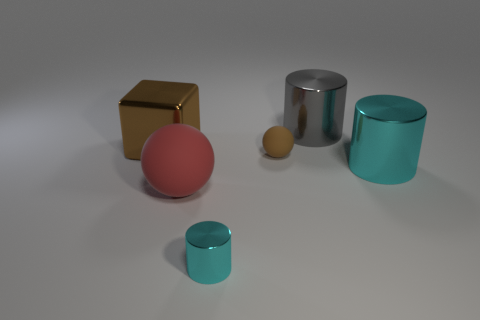Is the material of the large red ball the same as the small sphere?
Ensure brevity in your answer.  Yes. What number of things are either things on the left side of the tiny cyan metallic cylinder or spheres that are behind the red rubber sphere?
Your answer should be very brief. 3. What is the color of the small object that is the same shape as the big cyan shiny object?
Offer a terse response. Cyan. How many large shiny cylinders are the same color as the small rubber ball?
Offer a very short reply. 0. Does the block have the same color as the small sphere?
Keep it short and to the point. Yes. What number of things are either big things behind the block or small cyan matte cubes?
Provide a succinct answer. 1. The big cylinder that is in front of the large shiny cylinder behind the cyan metallic thing right of the small cyan object is what color?
Provide a succinct answer. Cyan. What is the color of the tiny object that is made of the same material as the big red thing?
Provide a short and direct response. Brown. What number of red objects are the same material as the big cube?
Your response must be concise. 0. Do the cyan metal thing to the left of the gray cylinder and the large matte object have the same size?
Your answer should be very brief. No. 